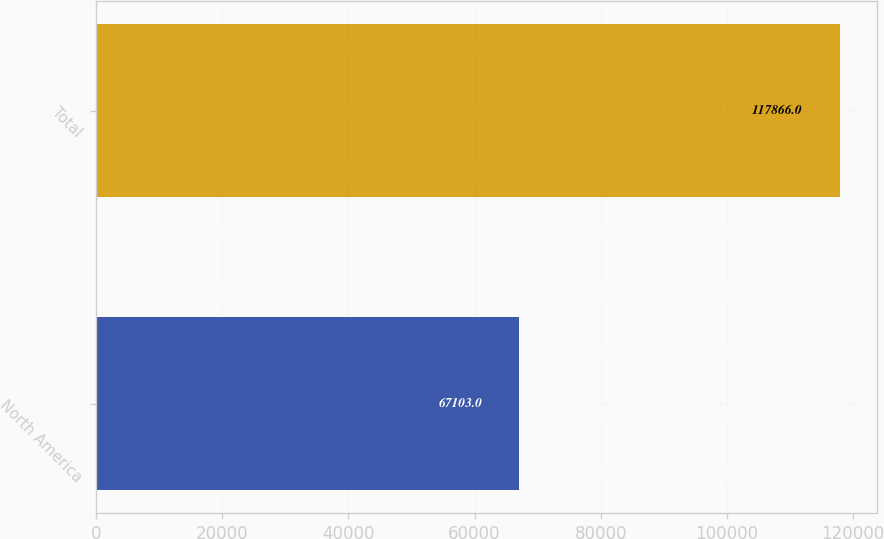Convert chart to OTSL. <chart><loc_0><loc_0><loc_500><loc_500><bar_chart><fcel>North America<fcel>Total<nl><fcel>67103<fcel>117866<nl></chart> 